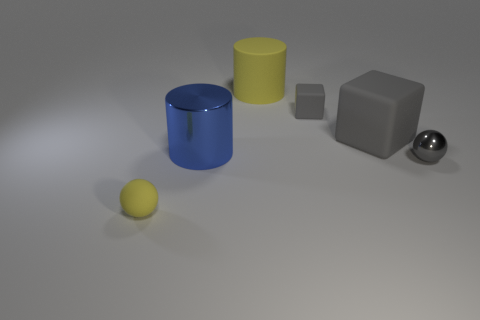What is the shape of the tiny rubber object that is the same color as the large cube?
Offer a very short reply. Cube. There is a sphere on the left side of the metallic object that is left of the large gray rubber cube; what color is it?
Your answer should be compact. Yellow. There is a tiny matte object that is in front of the tiny gray rubber cube; is it the same color as the rubber cylinder?
Provide a succinct answer. Yes. There is a tiny matte thing in front of the small gray thing in front of the cylinder in front of the big gray block; what is its shape?
Ensure brevity in your answer.  Sphere. How many gray rubber blocks are on the left side of the tiny matte thing that is on the right side of the big yellow matte cylinder?
Give a very brief answer. 0. Is the material of the blue cylinder the same as the gray sphere?
Your answer should be very brief. Yes. There is a tiny object in front of the metal thing on the right side of the tiny gray rubber thing; what number of small yellow rubber things are to the right of it?
Offer a terse response. 0. There is a large matte block on the right side of the small matte cube; what color is it?
Provide a short and direct response. Gray. The metallic thing that is on the right side of the tiny matte thing behind the big gray rubber thing is what shape?
Your response must be concise. Sphere. Is the color of the big matte cylinder the same as the tiny matte ball?
Your response must be concise. Yes. 